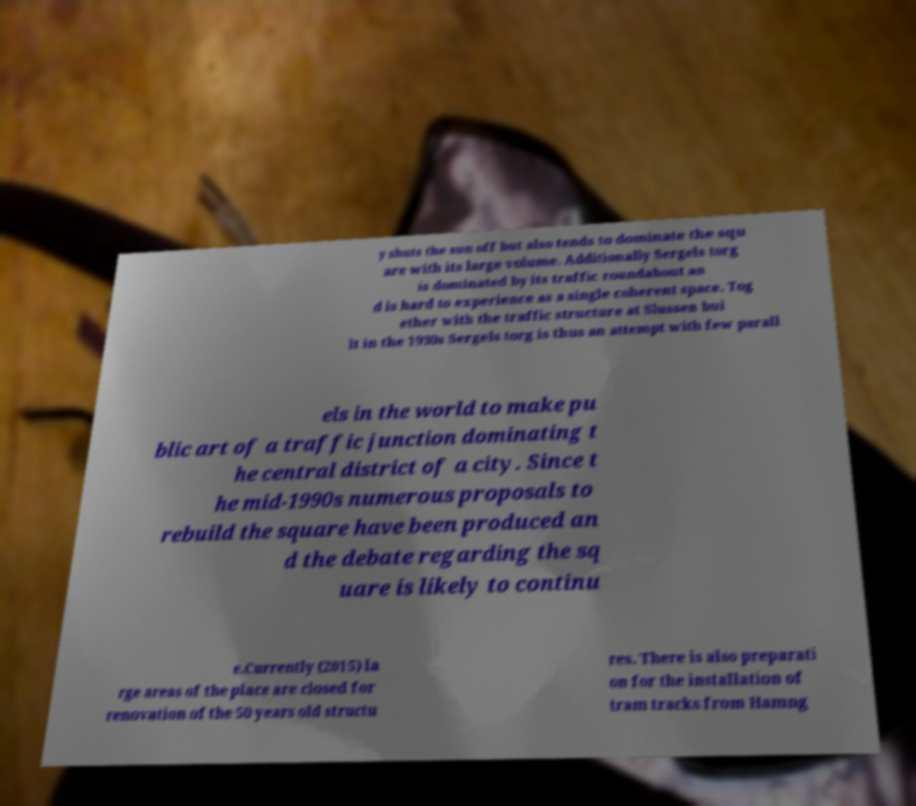For documentation purposes, I need the text within this image transcribed. Could you provide that? y shuts the sun off but also tends to dominate the squ are with its large volume. Additionally Sergels torg is dominated by its traffic roundabout an d is hard to experience as a single coherent space. Tog ether with the traffic structure at Slussen bui lt in the 1930s Sergels torg is thus an attempt with few parall els in the world to make pu blic art of a traffic junction dominating t he central district of a city. Since t he mid-1990s numerous proposals to rebuild the square have been produced an d the debate regarding the sq uare is likely to continu e.Currently (2015) la rge areas of the place are closed for renovation of the 50 years old structu res. There is also preparati on for the installation of tram tracks from Hamng 